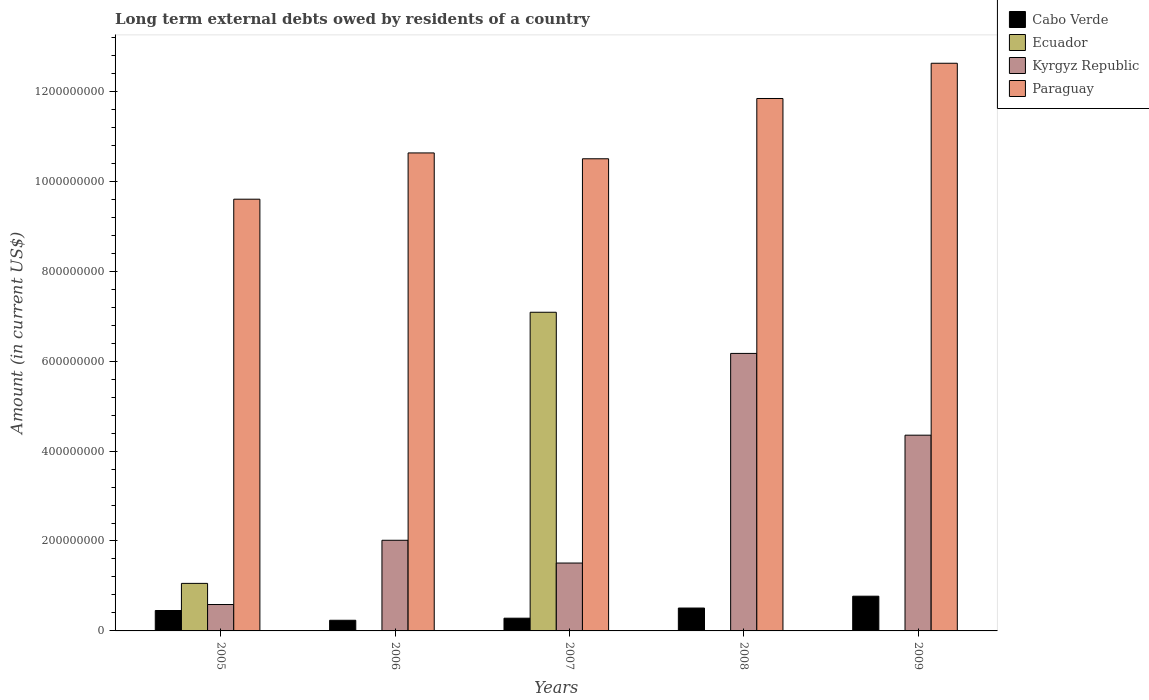Are the number of bars per tick equal to the number of legend labels?
Your answer should be compact. No. Are the number of bars on each tick of the X-axis equal?
Offer a very short reply. No. How many bars are there on the 4th tick from the right?
Make the answer very short. 3. In how many cases, is the number of bars for a given year not equal to the number of legend labels?
Make the answer very short. 3. What is the amount of long-term external debts owed by residents in Cabo Verde in 2009?
Keep it short and to the point. 7.72e+07. Across all years, what is the maximum amount of long-term external debts owed by residents in Ecuador?
Provide a succinct answer. 7.09e+08. What is the total amount of long-term external debts owed by residents in Kyrgyz Republic in the graph?
Ensure brevity in your answer.  1.46e+09. What is the difference between the amount of long-term external debts owed by residents in Paraguay in 2005 and that in 2008?
Offer a terse response. -2.24e+08. What is the difference between the amount of long-term external debts owed by residents in Kyrgyz Republic in 2005 and the amount of long-term external debts owed by residents in Paraguay in 2006?
Offer a very short reply. -1.00e+09. What is the average amount of long-term external debts owed by residents in Paraguay per year?
Your response must be concise. 1.10e+09. In the year 2009, what is the difference between the amount of long-term external debts owed by residents in Cabo Verde and amount of long-term external debts owed by residents in Paraguay?
Offer a terse response. -1.19e+09. What is the ratio of the amount of long-term external debts owed by residents in Cabo Verde in 2008 to that in 2009?
Keep it short and to the point. 0.66. What is the difference between the highest and the second highest amount of long-term external debts owed by residents in Kyrgyz Republic?
Give a very brief answer. 1.82e+08. What is the difference between the highest and the lowest amount of long-term external debts owed by residents in Kyrgyz Republic?
Keep it short and to the point. 5.58e+08. Is it the case that in every year, the sum of the amount of long-term external debts owed by residents in Ecuador and amount of long-term external debts owed by residents in Kyrgyz Republic is greater than the sum of amount of long-term external debts owed by residents in Paraguay and amount of long-term external debts owed by residents in Cabo Verde?
Provide a succinct answer. No. Are all the bars in the graph horizontal?
Keep it short and to the point. No. What is the difference between two consecutive major ticks on the Y-axis?
Ensure brevity in your answer.  2.00e+08. Does the graph contain grids?
Offer a very short reply. No. How are the legend labels stacked?
Your response must be concise. Vertical. What is the title of the graph?
Offer a terse response. Long term external debts owed by residents of a country. Does "Iran" appear as one of the legend labels in the graph?
Your answer should be compact. No. What is the label or title of the X-axis?
Offer a very short reply. Years. What is the Amount (in current US$) in Cabo Verde in 2005?
Make the answer very short. 4.54e+07. What is the Amount (in current US$) in Ecuador in 2005?
Your answer should be compact. 1.06e+08. What is the Amount (in current US$) in Kyrgyz Republic in 2005?
Provide a succinct answer. 5.87e+07. What is the Amount (in current US$) in Paraguay in 2005?
Offer a terse response. 9.60e+08. What is the Amount (in current US$) in Cabo Verde in 2006?
Provide a short and direct response. 2.37e+07. What is the Amount (in current US$) in Ecuador in 2006?
Keep it short and to the point. 0. What is the Amount (in current US$) in Kyrgyz Republic in 2006?
Your answer should be very brief. 2.02e+08. What is the Amount (in current US$) in Paraguay in 2006?
Provide a short and direct response. 1.06e+09. What is the Amount (in current US$) of Cabo Verde in 2007?
Your answer should be compact. 2.83e+07. What is the Amount (in current US$) of Ecuador in 2007?
Offer a very short reply. 7.09e+08. What is the Amount (in current US$) of Kyrgyz Republic in 2007?
Ensure brevity in your answer.  1.51e+08. What is the Amount (in current US$) of Paraguay in 2007?
Give a very brief answer. 1.05e+09. What is the Amount (in current US$) of Cabo Verde in 2008?
Your answer should be very brief. 5.09e+07. What is the Amount (in current US$) of Ecuador in 2008?
Your response must be concise. 0. What is the Amount (in current US$) in Kyrgyz Republic in 2008?
Provide a succinct answer. 6.17e+08. What is the Amount (in current US$) in Paraguay in 2008?
Offer a very short reply. 1.18e+09. What is the Amount (in current US$) in Cabo Verde in 2009?
Make the answer very short. 7.72e+07. What is the Amount (in current US$) of Ecuador in 2009?
Your answer should be very brief. 0. What is the Amount (in current US$) of Kyrgyz Republic in 2009?
Ensure brevity in your answer.  4.35e+08. What is the Amount (in current US$) in Paraguay in 2009?
Ensure brevity in your answer.  1.26e+09. Across all years, what is the maximum Amount (in current US$) of Cabo Verde?
Provide a short and direct response. 7.72e+07. Across all years, what is the maximum Amount (in current US$) in Ecuador?
Your response must be concise. 7.09e+08. Across all years, what is the maximum Amount (in current US$) of Kyrgyz Republic?
Offer a terse response. 6.17e+08. Across all years, what is the maximum Amount (in current US$) in Paraguay?
Provide a short and direct response. 1.26e+09. Across all years, what is the minimum Amount (in current US$) in Cabo Verde?
Ensure brevity in your answer.  2.37e+07. Across all years, what is the minimum Amount (in current US$) in Ecuador?
Provide a short and direct response. 0. Across all years, what is the minimum Amount (in current US$) in Kyrgyz Republic?
Your response must be concise. 5.87e+07. Across all years, what is the minimum Amount (in current US$) of Paraguay?
Make the answer very short. 9.60e+08. What is the total Amount (in current US$) in Cabo Verde in the graph?
Make the answer very short. 2.26e+08. What is the total Amount (in current US$) in Ecuador in the graph?
Provide a succinct answer. 8.14e+08. What is the total Amount (in current US$) in Kyrgyz Republic in the graph?
Make the answer very short. 1.46e+09. What is the total Amount (in current US$) in Paraguay in the graph?
Ensure brevity in your answer.  5.52e+09. What is the difference between the Amount (in current US$) in Cabo Verde in 2005 and that in 2006?
Your answer should be very brief. 2.17e+07. What is the difference between the Amount (in current US$) in Kyrgyz Republic in 2005 and that in 2006?
Your answer should be compact. -1.43e+08. What is the difference between the Amount (in current US$) in Paraguay in 2005 and that in 2006?
Your response must be concise. -1.03e+08. What is the difference between the Amount (in current US$) in Cabo Verde in 2005 and that in 2007?
Give a very brief answer. 1.71e+07. What is the difference between the Amount (in current US$) of Ecuador in 2005 and that in 2007?
Offer a very short reply. -6.03e+08. What is the difference between the Amount (in current US$) of Kyrgyz Republic in 2005 and that in 2007?
Give a very brief answer. -9.23e+07. What is the difference between the Amount (in current US$) of Paraguay in 2005 and that in 2007?
Your response must be concise. -8.99e+07. What is the difference between the Amount (in current US$) in Cabo Verde in 2005 and that in 2008?
Ensure brevity in your answer.  -5.48e+06. What is the difference between the Amount (in current US$) of Kyrgyz Republic in 2005 and that in 2008?
Your answer should be compact. -5.58e+08. What is the difference between the Amount (in current US$) in Paraguay in 2005 and that in 2008?
Provide a succinct answer. -2.24e+08. What is the difference between the Amount (in current US$) of Cabo Verde in 2005 and that in 2009?
Your answer should be very brief. -3.18e+07. What is the difference between the Amount (in current US$) of Kyrgyz Republic in 2005 and that in 2009?
Provide a short and direct response. -3.77e+08. What is the difference between the Amount (in current US$) of Paraguay in 2005 and that in 2009?
Give a very brief answer. -3.02e+08. What is the difference between the Amount (in current US$) of Cabo Verde in 2006 and that in 2007?
Give a very brief answer. -4.64e+06. What is the difference between the Amount (in current US$) of Kyrgyz Republic in 2006 and that in 2007?
Your answer should be compact. 5.06e+07. What is the difference between the Amount (in current US$) in Paraguay in 2006 and that in 2007?
Give a very brief answer. 1.30e+07. What is the difference between the Amount (in current US$) in Cabo Verde in 2006 and that in 2008?
Your answer should be compact. -2.72e+07. What is the difference between the Amount (in current US$) of Kyrgyz Republic in 2006 and that in 2008?
Provide a succinct answer. -4.16e+08. What is the difference between the Amount (in current US$) in Paraguay in 2006 and that in 2008?
Offer a very short reply. -1.21e+08. What is the difference between the Amount (in current US$) in Cabo Verde in 2006 and that in 2009?
Your answer should be compact. -5.36e+07. What is the difference between the Amount (in current US$) in Kyrgyz Republic in 2006 and that in 2009?
Your response must be concise. -2.34e+08. What is the difference between the Amount (in current US$) in Paraguay in 2006 and that in 2009?
Offer a terse response. -1.99e+08. What is the difference between the Amount (in current US$) of Cabo Verde in 2007 and that in 2008?
Give a very brief answer. -2.26e+07. What is the difference between the Amount (in current US$) of Kyrgyz Republic in 2007 and that in 2008?
Provide a succinct answer. -4.66e+08. What is the difference between the Amount (in current US$) of Paraguay in 2007 and that in 2008?
Your response must be concise. -1.34e+08. What is the difference between the Amount (in current US$) of Cabo Verde in 2007 and that in 2009?
Provide a succinct answer. -4.89e+07. What is the difference between the Amount (in current US$) of Kyrgyz Republic in 2007 and that in 2009?
Make the answer very short. -2.84e+08. What is the difference between the Amount (in current US$) in Paraguay in 2007 and that in 2009?
Provide a succinct answer. -2.12e+08. What is the difference between the Amount (in current US$) in Cabo Verde in 2008 and that in 2009?
Your response must be concise. -2.63e+07. What is the difference between the Amount (in current US$) of Kyrgyz Republic in 2008 and that in 2009?
Give a very brief answer. 1.82e+08. What is the difference between the Amount (in current US$) in Paraguay in 2008 and that in 2009?
Offer a very short reply. -7.84e+07. What is the difference between the Amount (in current US$) of Cabo Verde in 2005 and the Amount (in current US$) of Kyrgyz Republic in 2006?
Provide a succinct answer. -1.56e+08. What is the difference between the Amount (in current US$) of Cabo Verde in 2005 and the Amount (in current US$) of Paraguay in 2006?
Keep it short and to the point. -1.02e+09. What is the difference between the Amount (in current US$) in Ecuador in 2005 and the Amount (in current US$) in Kyrgyz Republic in 2006?
Offer a terse response. -9.59e+07. What is the difference between the Amount (in current US$) of Ecuador in 2005 and the Amount (in current US$) of Paraguay in 2006?
Make the answer very short. -9.57e+08. What is the difference between the Amount (in current US$) in Kyrgyz Republic in 2005 and the Amount (in current US$) in Paraguay in 2006?
Ensure brevity in your answer.  -1.00e+09. What is the difference between the Amount (in current US$) of Cabo Verde in 2005 and the Amount (in current US$) of Ecuador in 2007?
Offer a very short reply. -6.63e+08. What is the difference between the Amount (in current US$) in Cabo Verde in 2005 and the Amount (in current US$) in Kyrgyz Republic in 2007?
Your response must be concise. -1.06e+08. What is the difference between the Amount (in current US$) of Cabo Verde in 2005 and the Amount (in current US$) of Paraguay in 2007?
Offer a terse response. -1.00e+09. What is the difference between the Amount (in current US$) in Ecuador in 2005 and the Amount (in current US$) in Kyrgyz Republic in 2007?
Offer a terse response. -4.52e+07. What is the difference between the Amount (in current US$) in Ecuador in 2005 and the Amount (in current US$) in Paraguay in 2007?
Keep it short and to the point. -9.44e+08. What is the difference between the Amount (in current US$) of Kyrgyz Republic in 2005 and the Amount (in current US$) of Paraguay in 2007?
Your response must be concise. -9.91e+08. What is the difference between the Amount (in current US$) of Cabo Verde in 2005 and the Amount (in current US$) of Kyrgyz Republic in 2008?
Your answer should be compact. -5.72e+08. What is the difference between the Amount (in current US$) of Cabo Verde in 2005 and the Amount (in current US$) of Paraguay in 2008?
Provide a short and direct response. -1.14e+09. What is the difference between the Amount (in current US$) in Ecuador in 2005 and the Amount (in current US$) in Kyrgyz Republic in 2008?
Provide a short and direct response. -5.11e+08. What is the difference between the Amount (in current US$) in Ecuador in 2005 and the Amount (in current US$) in Paraguay in 2008?
Give a very brief answer. -1.08e+09. What is the difference between the Amount (in current US$) in Kyrgyz Republic in 2005 and the Amount (in current US$) in Paraguay in 2008?
Provide a succinct answer. -1.13e+09. What is the difference between the Amount (in current US$) in Cabo Verde in 2005 and the Amount (in current US$) in Kyrgyz Republic in 2009?
Your answer should be very brief. -3.90e+08. What is the difference between the Amount (in current US$) in Cabo Verde in 2005 and the Amount (in current US$) in Paraguay in 2009?
Give a very brief answer. -1.22e+09. What is the difference between the Amount (in current US$) of Ecuador in 2005 and the Amount (in current US$) of Kyrgyz Republic in 2009?
Provide a succinct answer. -3.30e+08. What is the difference between the Amount (in current US$) in Ecuador in 2005 and the Amount (in current US$) in Paraguay in 2009?
Your answer should be compact. -1.16e+09. What is the difference between the Amount (in current US$) in Kyrgyz Republic in 2005 and the Amount (in current US$) in Paraguay in 2009?
Give a very brief answer. -1.20e+09. What is the difference between the Amount (in current US$) of Cabo Verde in 2006 and the Amount (in current US$) of Ecuador in 2007?
Provide a succinct answer. -6.85e+08. What is the difference between the Amount (in current US$) of Cabo Verde in 2006 and the Amount (in current US$) of Kyrgyz Republic in 2007?
Offer a very short reply. -1.27e+08. What is the difference between the Amount (in current US$) of Cabo Verde in 2006 and the Amount (in current US$) of Paraguay in 2007?
Keep it short and to the point. -1.03e+09. What is the difference between the Amount (in current US$) of Kyrgyz Republic in 2006 and the Amount (in current US$) of Paraguay in 2007?
Your answer should be very brief. -8.48e+08. What is the difference between the Amount (in current US$) in Cabo Verde in 2006 and the Amount (in current US$) in Kyrgyz Republic in 2008?
Your answer should be very brief. -5.93e+08. What is the difference between the Amount (in current US$) of Cabo Verde in 2006 and the Amount (in current US$) of Paraguay in 2008?
Keep it short and to the point. -1.16e+09. What is the difference between the Amount (in current US$) of Kyrgyz Republic in 2006 and the Amount (in current US$) of Paraguay in 2008?
Provide a succinct answer. -9.82e+08. What is the difference between the Amount (in current US$) of Cabo Verde in 2006 and the Amount (in current US$) of Kyrgyz Republic in 2009?
Keep it short and to the point. -4.12e+08. What is the difference between the Amount (in current US$) of Cabo Verde in 2006 and the Amount (in current US$) of Paraguay in 2009?
Provide a short and direct response. -1.24e+09. What is the difference between the Amount (in current US$) of Kyrgyz Republic in 2006 and the Amount (in current US$) of Paraguay in 2009?
Offer a very short reply. -1.06e+09. What is the difference between the Amount (in current US$) in Cabo Verde in 2007 and the Amount (in current US$) in Kyrgyz Republic in 2008?
Your response must be concise. -5.89e+08. What is the difference between the Amount (in current US$) of Cabo Verde in 2007 and the Amount (in current US$) of Paraguay in 2008?
Offer a very short reply. -1.16e+09. What is the difference between the Amount (in current US$) in Ecuador in 2007 and the Amount (in current US$) in Kyrgyz Republic in 2008?
Your answer should be very brief. 9.16e+07. What is the difference between the Amount (in current US$) of Ecuador in 2007 and the Amount (in current US$) of Paraguay in 2008?
Offer a very short reply. -4.75e+08. What is the difference between the Amount (in current US$) of Kyrgyz Republic in 2007 and the Amount (in current US$) of Paraguay in 2008?
Your answer should be very brief. -1.03e+09. What is the difference between the Amount (in current US$) of Cabo Verde in 2007 and the Amount (in current US$) of Kyrgyz Republic in 2009?
Your response must be concise. -4.07e+08. What is the difference between the Amount (in current US$) of Cabo Verde in 2007 and the Amount (in current US$) of Paraguay in 2009?
Provide a short and direct response. -1.23e+09. What is the difference between the Amount (in current US$) in Ecuador in 2007 and the Amount (in current US$) in Kyrgyz Republic in 2009?
Your answer should be very brief. 2.73e+08. What is the difference between the Amount (in current US$) in Ecuador in 2007 and the Amount (in current US$) in Paraguay in 2009?
Make the answer very short. -5.54e+08. What is the difference between the Amount (in current US$) in Kyrgyz Republic in 2007 and the Amount (in current US$) in Paraguay in 2009?
Make the answer very short. -1.11e+09. What is the difference between the Amount (in current US$) in Cabo Verde in 2008 and the Amount (in current US$) in Kyrgyz Republic in 2009?
Make the answer very short. -3.84e+08. What is the difference between the Amount (in current US$) of Cabo Verde in 2008 and the Amount (in current US$) of Paraguay in 2009?
Offer a terse response. -1.21e+09. What is the difference between the Amount (in current US$) of Kyrgyz Republic in 2008 and the Amount (in current US$) of Paraguay in 2009?
Give a very brief answer. -6.45e+08. What is the average Amount (in current US$) in Cabo Verde per year?
Offer a terse response. 4.51e+07. What is the average Amount (in current US$) in Ecuador per year?
Offer a terse response. 1.63e+08. What is the average Amount (in current US$) of Kyrgyz Republic per year?
Give a very brief answer. 2.93e+08. What is the average Amount (in current US$) in Paraguay per year?
Provide a short and direct response. 1.10e+09. In the year 2005, what is the difference between the Amount (in current US$) in Cabo Verde and Amount (in current US$) in Ecuador?
Offer a terse response. -6.03e+07. In the year 2005, what is the difference between the Amount (in current US$) of Cabo Verde and Amount (in current US$) of Kyrgyz Republic?
Provide a succinct answer. -1.33e+07. In the year 2005, what is the difference between the Amount (in current US$) in Cabo Verde and Amount (in current US$) in Paraguay?
Provide a short and direct response. -9.15e+08. In the year 2005, what is the difference between the Amount (in current US$) of Ecuador and Amount (in current US$) of Kyrgyz Republic?
Provide a short and direct response. 4.70e+07. In the year 2005, what is the difference between the Amount (in current US$) in Ecuador and Amount (in current US$) in Paraguay?
Your answer should be very brief. -8.54e+08. In the year 2005, what is the difference between the Amount (in current US$) in Kyrgyz Republic and Amount (in current US$) in Paraguay?
Give a very brief answer. -9.01e+08. In the year 2006, what is the difference between the Amount (in current US$) of Cabo Verde and Amount (in current US$) of Kyrgyz Republic?
Give a very brief answer. -1.78e+08. In the year 2006, what is the difference between the Amount (in current US$) in Cabo Verde and Amount (in current US$) in Paraguay?
Make the answer very short. -1.04e+09. In the year 2006, what is the difference between the Amount (in current US$) in Kyrgyz Republic and Amount (in current US$) in Paraguay?
Provide a short and direct response. -8.61e+08. In the year 2007, what is the difference between the Amount (in current US$) of Cabo Verde and Amount (in current US$) of Ecuador?
Your answer should be compact. -6.80e+08. In the year 2007, what is the difference between the Amount (in current US$) of Cabo Verde and Amount (in current US$) of Kyrgyz Republic?
Offer a terse response. -1.23e+08. In the year 2007, what is the difference between the Amount (in current US$) in Cabo Verde and Amount (in current US$) in Paraguay?
Your answer should be compact. -1.02e+09. In the year 2007, what is the difference between the Amount (in current US$) of Ecuador and Amount (in current US$) of Kyrgyz Republic?
Your answer should be very brief. 5.58e+08. In the year 2007, what is the difference between the Amount (in current US$) in Ecuador and Amount (in current US$) in Paraguay?
Your answer should be very brief. -3.41e+08. In the year 2007, what is the difference between the Amount (in current US$) of Kyrgyz Republic and Amount (in current US$) of Paraguay?
Your answer should be very brief. -8.99e+08. In the year 2008, what is the difference between the Amount (in current US$) of Cabo Verde and Amount (in current US$) of Kyrgyz Republic?
Make the answer very short. -5.66e+08. In the year 2008, what is the difference between the Amount (in current US$) of Cabo Verde and Amount (in current US$) of Paraguay?
Offer a very short reply. -1.13e+09. In the year 2008, what is the difference between the Amount (in current US$) of Kyrgyz Republic and Amount (in current US$) of Paraguay?
Provide a succinct answer. -5.67e+08. In the year 2009, what is the difference between the Amount (in current US$) of Cabo Verde and Amount (in current US$) of Kyrgyz Republic?
Offer a terse response. -3.58e+08. In the year 2009, what is the difference between the Amount (in current US$) in Cabo Verde and Amount (in current US$) in Paraguay?
Provide a short and direct response. -1.19e+09. In the year 2009, what is the difference between the Amount (in current US$) in Kyrgyz Republic and Amount (in current US$) in Paraguay?
Offer a very short reply. -8.27e+08. What is the ratio of the Amount (in current US$) of Cabo Verde in 2005 to that in 2006?
Your answer should be very brief. 1.92. What is the ratio of the Amount (in current US$) in Kyrgyz Republic in 2005 to that in 2006?
Your answer should be very brief. 0.29. What is the ratio of the Amount (in current US$) of Paraguay in 2005 to that in 2006?
Offer a very short reply. 0.9. What is the ratio of the Amount (in current US$) in Cabo Verde in 2005 to that in 2007?
Your answer should be very brief. 1.6. What is the ratio of the Amount (in current US$) of Ecuador in 2005 to that in 2007?
Keep it short and to the point. 0.15. What is the ratio of the Amount (in current US$) in Kyrgyz Republic in 2005 to that in 2007?
Provide a short and direct response. 0.39. What is the ratio of the Amount (in current US$) in Paraguay in 2005 to that in 2007?
Ensure brevity in your answer.  0.91. What is the ratio of the Amount (in current US$) of Cabo Verde in 2005 to that in 2008?
Make the answer very short. 0.89. What is the ratio of the Amount (in current US$) of Kyrgyz Republic in 2005 to that in 2008?
Offer a terse response. 0.1. What is the ratio of the Amount (in current US$) in Paraguay in 2005 to that in 2008?
Provide a short and direct response. 0.81. What is the ratio of the Amount (in current US$) of Cabo Verde in 2005 to that in 2009?
Offer a very short reply. 0.59. What is the ratio of the Amount (in current US$) in Kyrgyz Republic in 2005 to that in 2009?
Provide a succinct answer. 0.13. What is the ratio of the Amount (in current US$) in Paraguay in 2005 to that in 2009?
Ensure brevity in your answer.  0.76. What is the ratio of the Amount (in current US$) of Cabo Verde in 2006 to that in 2007?
Give a very brief answer. 0.84. What is the ratio of the Amount (in current US$) of Kyrgyz Republic in 2006 to that in 2007?
Make the answer very short. 1.34. What is the ratio of the Amount (in current US$) of Paraguay in 2006 to that in 2007?
Offer a very short reply. 1.01. What is the ratio of the Amount (in current US$) in Cabo Verde in 2006 to that in 2008?
Provide a succinct answer. 0.47. What is the ratio of the Amount (in current US$) in Kyrgyz Republic in 2006 to that in 2008?
Your answer should be compact. 0.33. What is the ratio of the Amount (in current US$) of Paraguay in 2006 to that in 2008?
Your answer should be very brief. 0.9. What is the ratio of the Amount (in current US$) in Cabo Verde in 2006 to that in 2009?
Provide a short and direct response. 0.31. What is the ratio of the Amount (in current US$) of Kyrgyz Republic in 2006 to that in 2009?
Offer a terse response. 0.46. What is the ratio of the Amount (in current US$) in Paraguay in 2006 to that in 2009?
Provide a short and direct response. 0.84. What is the ratio of the Amount (in current US$) of Cabo Verde in 2007 to that in 2008?
Ensure brevity in your answer.  0.56. What is the ratio of the Amount (in current US$) of Kyrgyz Republic in 2007 to that in 2008?
Offer a very short reply. 0.24. What is the ratio of the Amount (in current US$) of Paraguay in 2007 to that in 2008?
Your answer should be compact. 0.89. What is the ratio of the Amount (in current US$) in Cabo Verde in 2007 to that in 2009?
Offer a very short reply. 0.37. What is the ratio of the Amount (in current US$) in Kyrgyz Republic in 2007 to that in 2009?
Provide a succinct answer. 0.35. What is the ratio of the Amount (in current US$) of Paraguay in 2007 to that in 2009?
Give a very brief answer. 0.83. What is the ratio of the Amount (in current US$) in Cabo Verde in 2008 to that in 2009?
Provide a succinct answer. 0.66. What is the ratio of the Amount (in current US$) in Kyrgyz Republic in 2008 to that in 2009?
Keep it short and to the point. 1.42. What is the ratio of the Amount (in current US$) of Paraguay in 2008 to that in 2009?
Your response must be concise. 0.94. What is the difference between the highest and the second highest Amount (in current US$) in Cabo Verde?
Offer a very short reply. 2.63e+07. What is the difference between the highest and the second highest Amount (in current US$) in Kyrgyz Republic?
Give a very brief answer. 1.82e+08. What is the difference between the highest and the second highest Amount (in current US$) of Paraguay?
Offer a very short reply. 7.84e+07. What is the difference between the highest and the lowest Amount (in current US$) in Cabo Verde?
Provide a short and direct response. 5.36e+07. What is the difference between the highest and the lowest Amount (in current US$) of Ecuador?
Offer a terse response. 7.09e+08. What is the difference between the highest and the lowest Amount (in current US$) of Kyrgyz Republic?
Ensure brevity in your answer.  5.58e+08. What is the difference between the highest and the lowest Amount (in current US$) in Paraguay?
Your answer should be compact. 3.02e+08. 